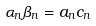<formula> <loc_0><loc_0><loc_500><loc_500>\alpha _ { n } \beta _ { n } = a _ { n } c _ { n }</formula> 